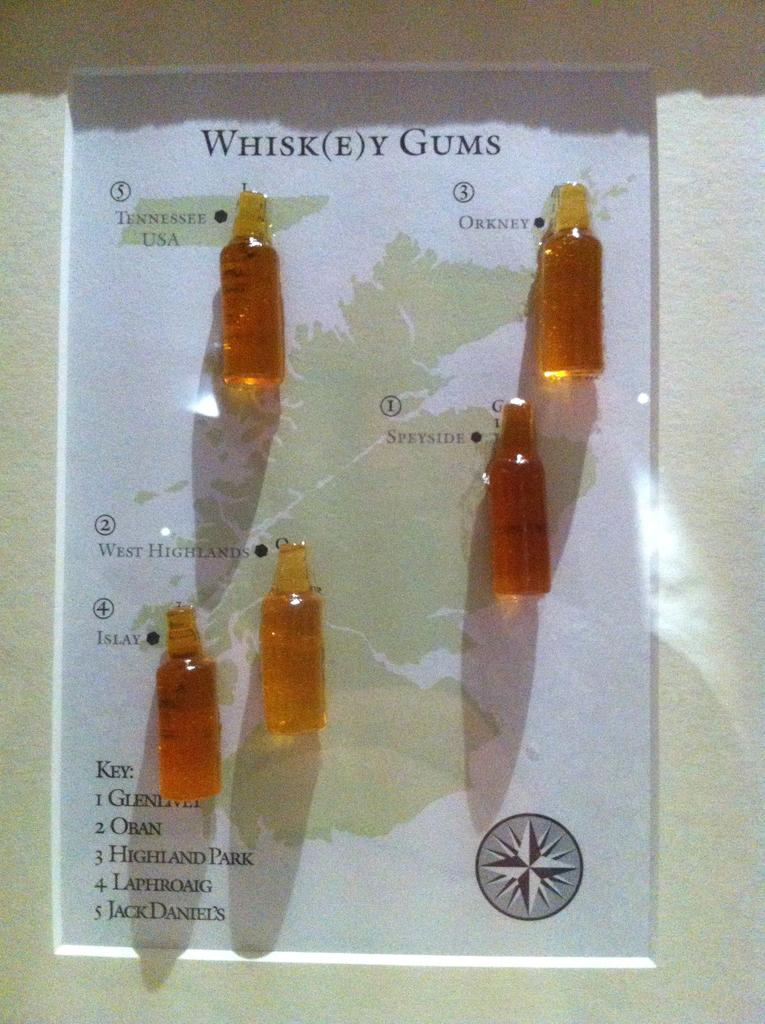Provide a one-sentence caption for the provided image. a number of whiskey gums pinned to a map of Scotland. 